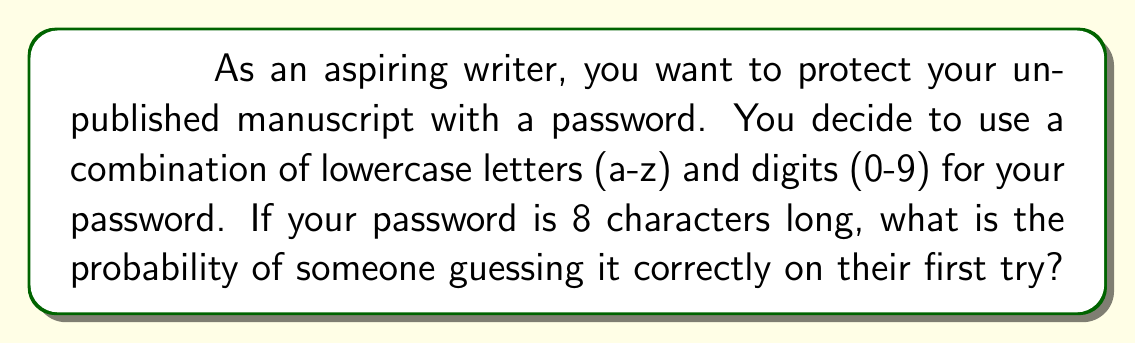Help me with this question. Let's approach this step-by-step:

1) First, we need to determine the total number of possible characters:
   - 26 lowercase letters (a-z)
   - 10 digits (0-9)
   Total: 26 + 10 = 36 possible characters

2) For each character position, there are 36 choices.

3) The password is 8 characters long, so we need to calculate the total number of possible passwords.

4) This is a case of independent events, so we multiply the number of choices for each position:

   $$ \text{Total possible passwords} = 36^8 $$

5) The probability of guessing correctly is 1 divided by the total number of possible passwords:

   $$ P(\text{correct guess}) = \frac{1}{36^8} $$

6) Let's calculate this:

   $$ P(\text{correct guess}) = \frac{1}{36^8} = \frac{1}{2,821,109,907,456} \approx 3.544 \times 10^{-13} $$

This extremely small probability demonstrates how effective even a moderately complex password can be against random guessing attacks.
Answer: $\frac{1}{36^8}$ or approximately $3.544 \times 10^{-13}$ 